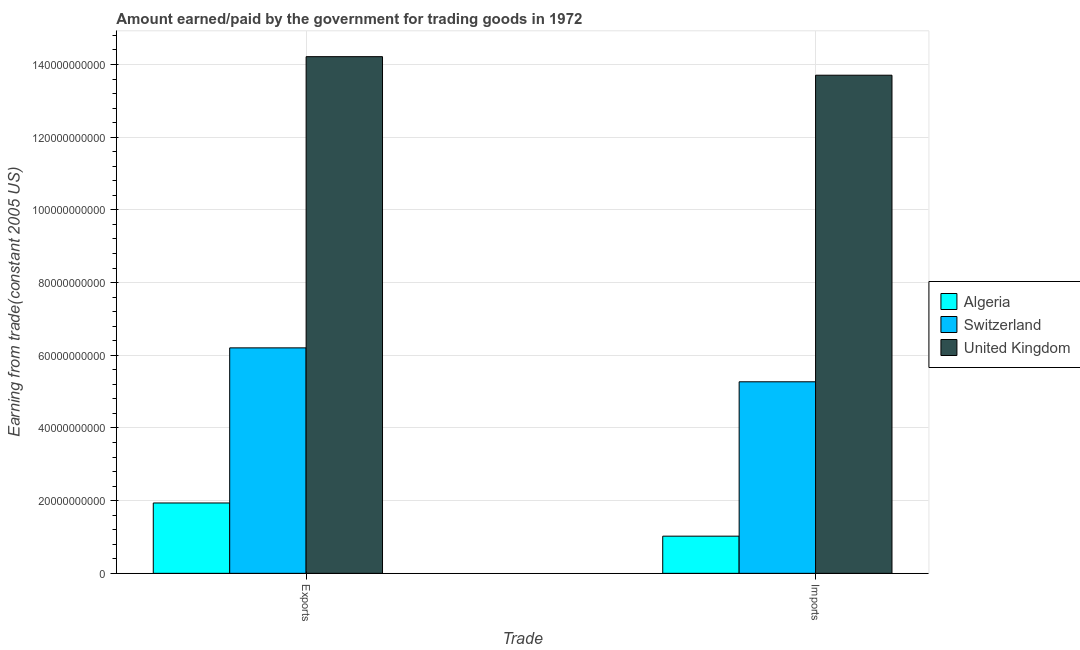How many different coloured bars are there?
Give a very brief answer. 3. Are the number of bars on each tick of the X-axis equal?
Offer a terse response. Yes. How many bars are there on the 2nd tick from the left?
Offer a very short reply. 3. What is the label of the 1st group of bars from the left?
Make the answer very short. Exports. What is the amount earned from exports in Algeria?
Your response must be concise. 1.94e+1. Across all countries, what is the maximum amount earned from exports?
Keep it short and to the point. 1.42e+11. Across all countries, what is the minimum amount earned from exports?
Your answer should be compact. 1.94e+1. In which country was the amount earned from exports maximum?
Provide a succinct answer. United Kingdom. In which country was the amount earned from exports minimum?
Your response must be concise. Algeria. What is the total amount earned from exports in the graph?
Offer a very short reply. 2.24e+11. What is the difference between the amount paid for imports in Algeria and that in Switzerland?
Your answer should be very brief. -4.25e+1. What is the difference between the amount earned from exports in Switzerland and the amount paid for imports in United Kingdom?
Provide a short and direct response. -7.50e+1. What is the average amount paid for imports per country?
Keep it short and to the point. 6.67e+1. What is the difference between the amount earned from exports and amount paid for imports in Switzerland?
Provide a short and direct response. 9.33e+09. What is the ratio of the amount paid for imports in Switzerland to that in United Kingdom?
Your answer should be compact. 0.38. In how many countries, is the amount earned from exports greater than the average amount earned from exports taken over all countries?
Keep it short and to the point. 1. What does the 1st bar from the left in Imports represents?
Your response must be concise. Algeria. What does the 1st bar from the right in Imports represents?
Offer a very short reply. United Kingdom. How many bars are there?
Your answer should be very brief. 6. Are all the bars in the graph horizontal?
Provide a short and direct response. No. Does the graph contain grids?
Offer a very short reply. Yes. Where does the legend appear in the graph?
Keep it short and to the point. Center right. How many legend labels are there?
Your response must be concise. 3. How are the legend labels stacked?
Your response must be concise. Vertical. What is the title of the graph?
Keep it short and to the point. Amount earned/paid by the government for trading goods in 1972. What is the label or title of the X-axis?
Your response must be concise. Trade. What is the label or title of the Y-axis?
Make the answer very short. Earning from trade(constant 2005 US). What is the Earning from trade(constant 2005 US) in Algeria in Exports?
Provide a succinct answer. 1.94e+1. What is the Earning from trade(constant 2005 US) of Switzerland in Exports?
Offer a terse response. 6.20e+1. What is the Earning from trade(constant 2005 US) of United Kingdom in Exports?
Your response must be concise. 1.42e+11. What is the Earning from trade(constant 2005 US) in Algeria in Imports?
Your response must be concise. 1.02e+1. What is the Earning from trade(constant 2005 US) in Switzerland in Imports?
Ensure brevity in your answer.  5.27e+1. What is the Earning from trade(constant 2005 US) of United Kingdom in Imports?
Provide a succinct answer. 1.37e+11. Across all Trade, what is the maximum Earning from trade(constant 2005 US) in Algeria?
Your answer should be compact. 1.94e+1. Across all Trade, what is the maximum Earning from trade(constant 2005 US) of Switzerland?
Your response must be concise. 6.20e+1. Across all Trade, what is the maximum Earning from trade(constant 2005 US) in United Kingdom?
Give a very brief answer. 1.42e+11. Across all Trade, what is the minimum Earning from trade(constant 2005 US) in Algeria?
Give a very brief answer. 1.02e+1. Across all Trade, what is the minimum Earning from trade(constant 2005 US) of Switzerland?
Your answer should be compact. 5.27e+1. Across all Trade, what is the minimum Earning from trade(constant 2005 US) in United Kingdom?
Provide a succinct answer. 1.37e+11. What is the total Earning from trade(constant 2005 US) in Algeria in the graph?
Your answer should be compact. 2.96e+1. What is the total Earning from trade(constant 2005 US) in Switzerland in the graph?
Your answer should be very brief. 1.15e+11. What is the total Earning from trade(constant 2005 US) of United Kingdom in the graph?
Your response must be concise. 2.79e+11. What is the difference between the Earning from trade(constant 2005 US) of Algeria in Exports and that in Imports?
Offer a very short reply. 9.13e+09. What is the difference between the Earning from trade(constant 2005 US) of Switzerland in Exports and that in Imports?
Your answer should be very brief. 9.33e+09. What is the difference between the Earning from trade(constant 2005 US) in United Kingdom in Exports and that in Imports?
Your answer should be compact. 5.10e+09. What is the difference between the Earning from trade(constant 2005 US) in Algeria in Exports and the Earning from trade(constant 2005 US) in Switzerland in Imports?
Provide a short and direct response. -3.33e+1. What is the difference between the Earning from trade(constant 2005 US) of Algeria in Exports and the Earning from trade(constant 2005 US) of United Kingdom in Imports?
Provide a succinct answer. -1.18e+11. What is the difference between the Earning from trade(constant 2005 US) of Switzerland in Exports and the Earning from trade(constant 2005 US) of United Kingdom in Imports?
Provide a succinct answer. -7.50e+1. What is the average Earning from trade(constant 2005 US) in Algeria per Trade?
Your answer should be compact. 1.48e+1. What is the average Earning from trade(constant 2005 US) of Switzerland per Trade?
Keep it short and to the point. 5.74e+1. What is the average Earning from trade(constant 2005 US) in United Kingdom per Trade?
Your answer should be very brief. 1.40e+11. What is the difference between the Earning from trade(constant 2005 US) in Algeria and Earning from trade(constant 2005 US) in Switzerland in Exports?
Your response must be concise. -4.27e+1. What is the difference between the Earning from trade(constant 2005 US) in Algeria and Earning from trade(constant 2005 US) in United Kingdom in Exports?
Make the answer very short. -1.23e+11. What is the difference between the Earning from trade(constant 2005 US) in Switzerland and Earning from trade(constant 2005 US) in United Kingdom in Exports?
Your response must be concise. -8.01e+1. What is the difference between the Earning from trade(constant 2005 US) of Algeria and Earning from trade(constant 2005 US) of Switzerland in Imports?
Offer a terse response. -4.25e+1. What is the difference between the Earning from trade(constant 2005 US) of Algeria and Earning from trade(constant 2005 US) of United Kingdom in Imports?
Give a very brief answer. -1.27e+11. What is the difference between the Earning from trade(constant 2005 US) in Switzerland and Earning from trade(constant 2005 US) in United Kingdom in Imports?
Make the answer very short. -8.44e+1. What is the ratio of the Earning from trade(constant 2005 US) in Algeria in Exports to that in Imports?
Offer a very short reply. 1.89. What is the ratio of the Earning from trade(constant 2005 US) in Switzerland in Exports to that in Imports?
Your answer should be very brief. 1.18. What is the ratio of the Earning from trade(constant 2005 US) in United Kingdom in Exports to that in Imports?
Offer a terse response. 1.04. What is the difference between the highest and the second highest Earning from trade(constant 2005 US) of Algeria?
Provide a short and direct response. 9.13e+09. What is the difference between the highest and the second highest Earning from trade(constant 2005 US) of Switzerland?
Your answer should be very brief. 9.33e+09. What is the difference between the highest and the second highest Earning from trade(constant 2005 US) in United Kingdom?
Offer a terse response. 5.10e+09. What is the difference between the highest and the lowest Earning from trade(constant 2005 US) in Algeria?
Your answer should be compact. 9.13e+09. What is the difference between the highest and the lowest Earning from trade(constant 2005 US) in Switzerland?
Offer a terse response. 9.33e+09. What is the difference between the highest and the lowest Earning from trade(constant 2005 US) of United Kingdom?
Give a very brief answer. 5.10e+09. 